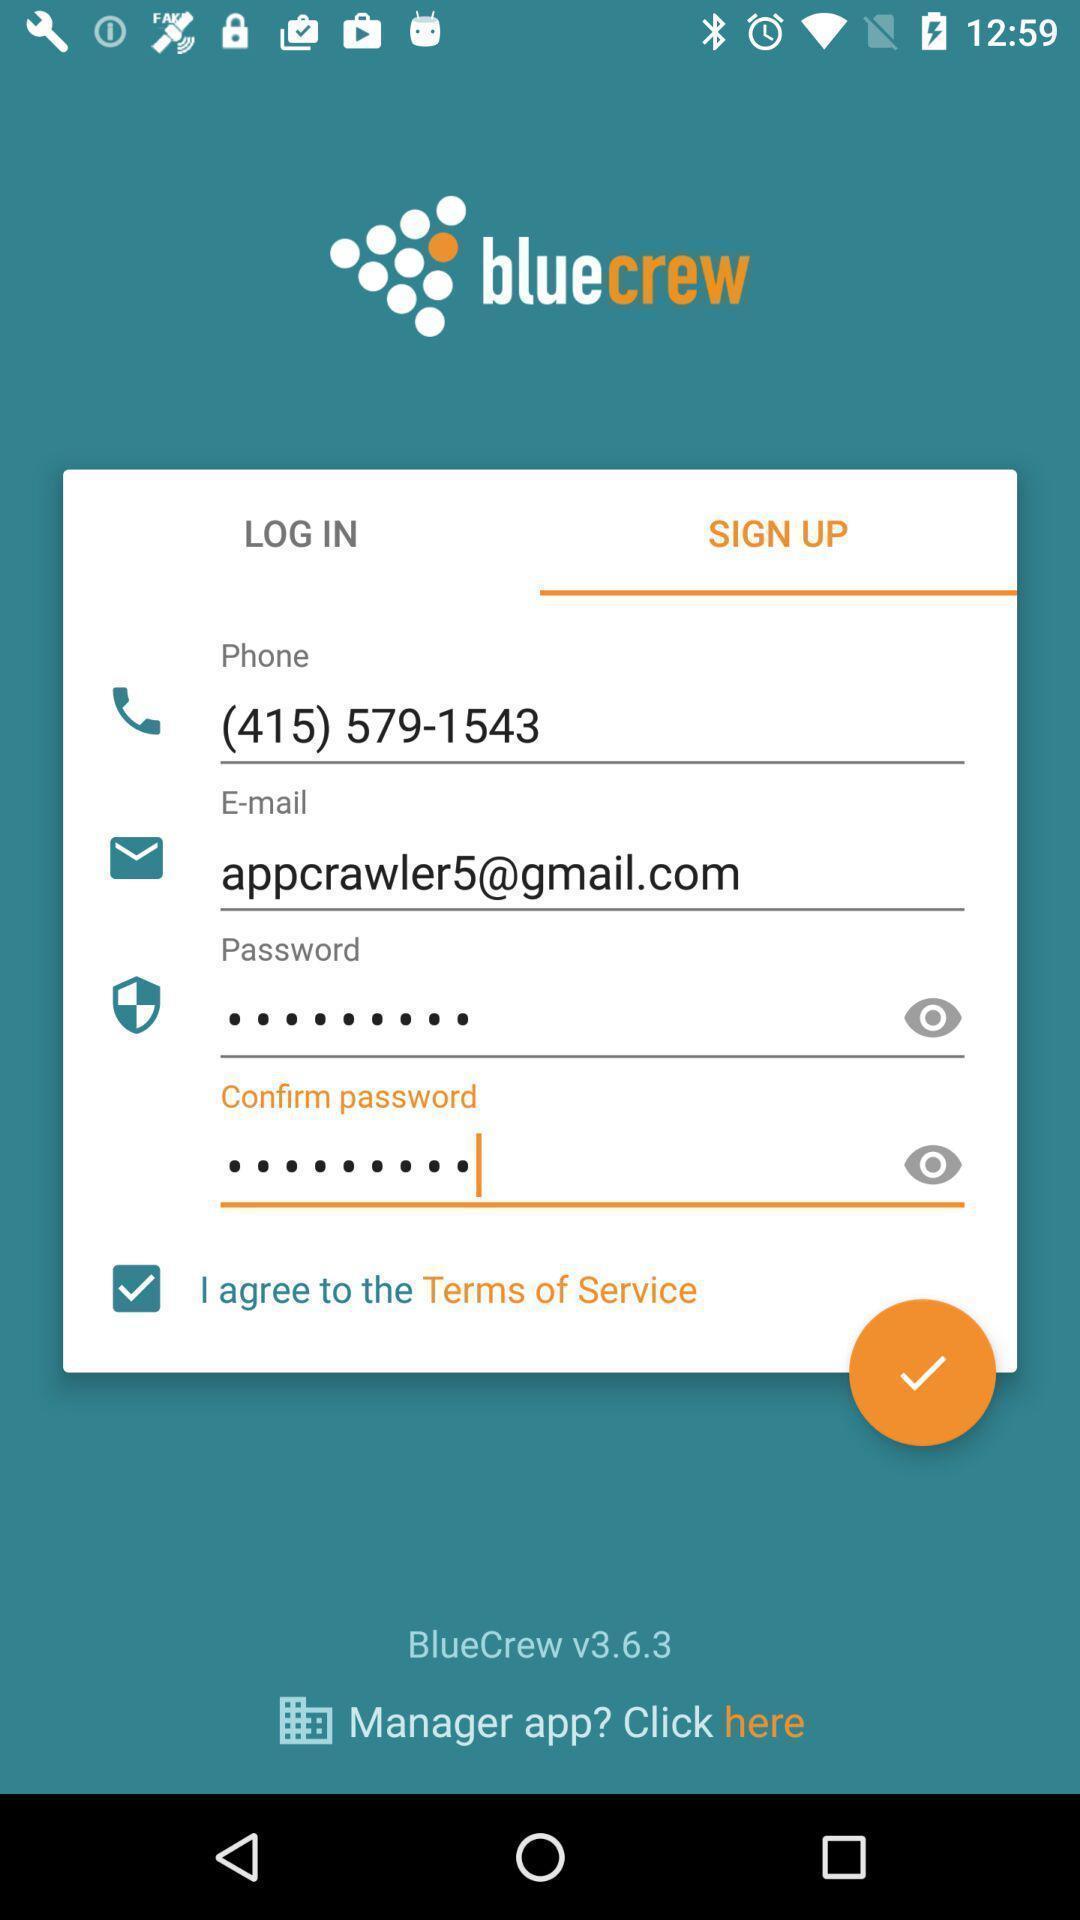Provide a detailed account of this screenshot. Sign up page. 